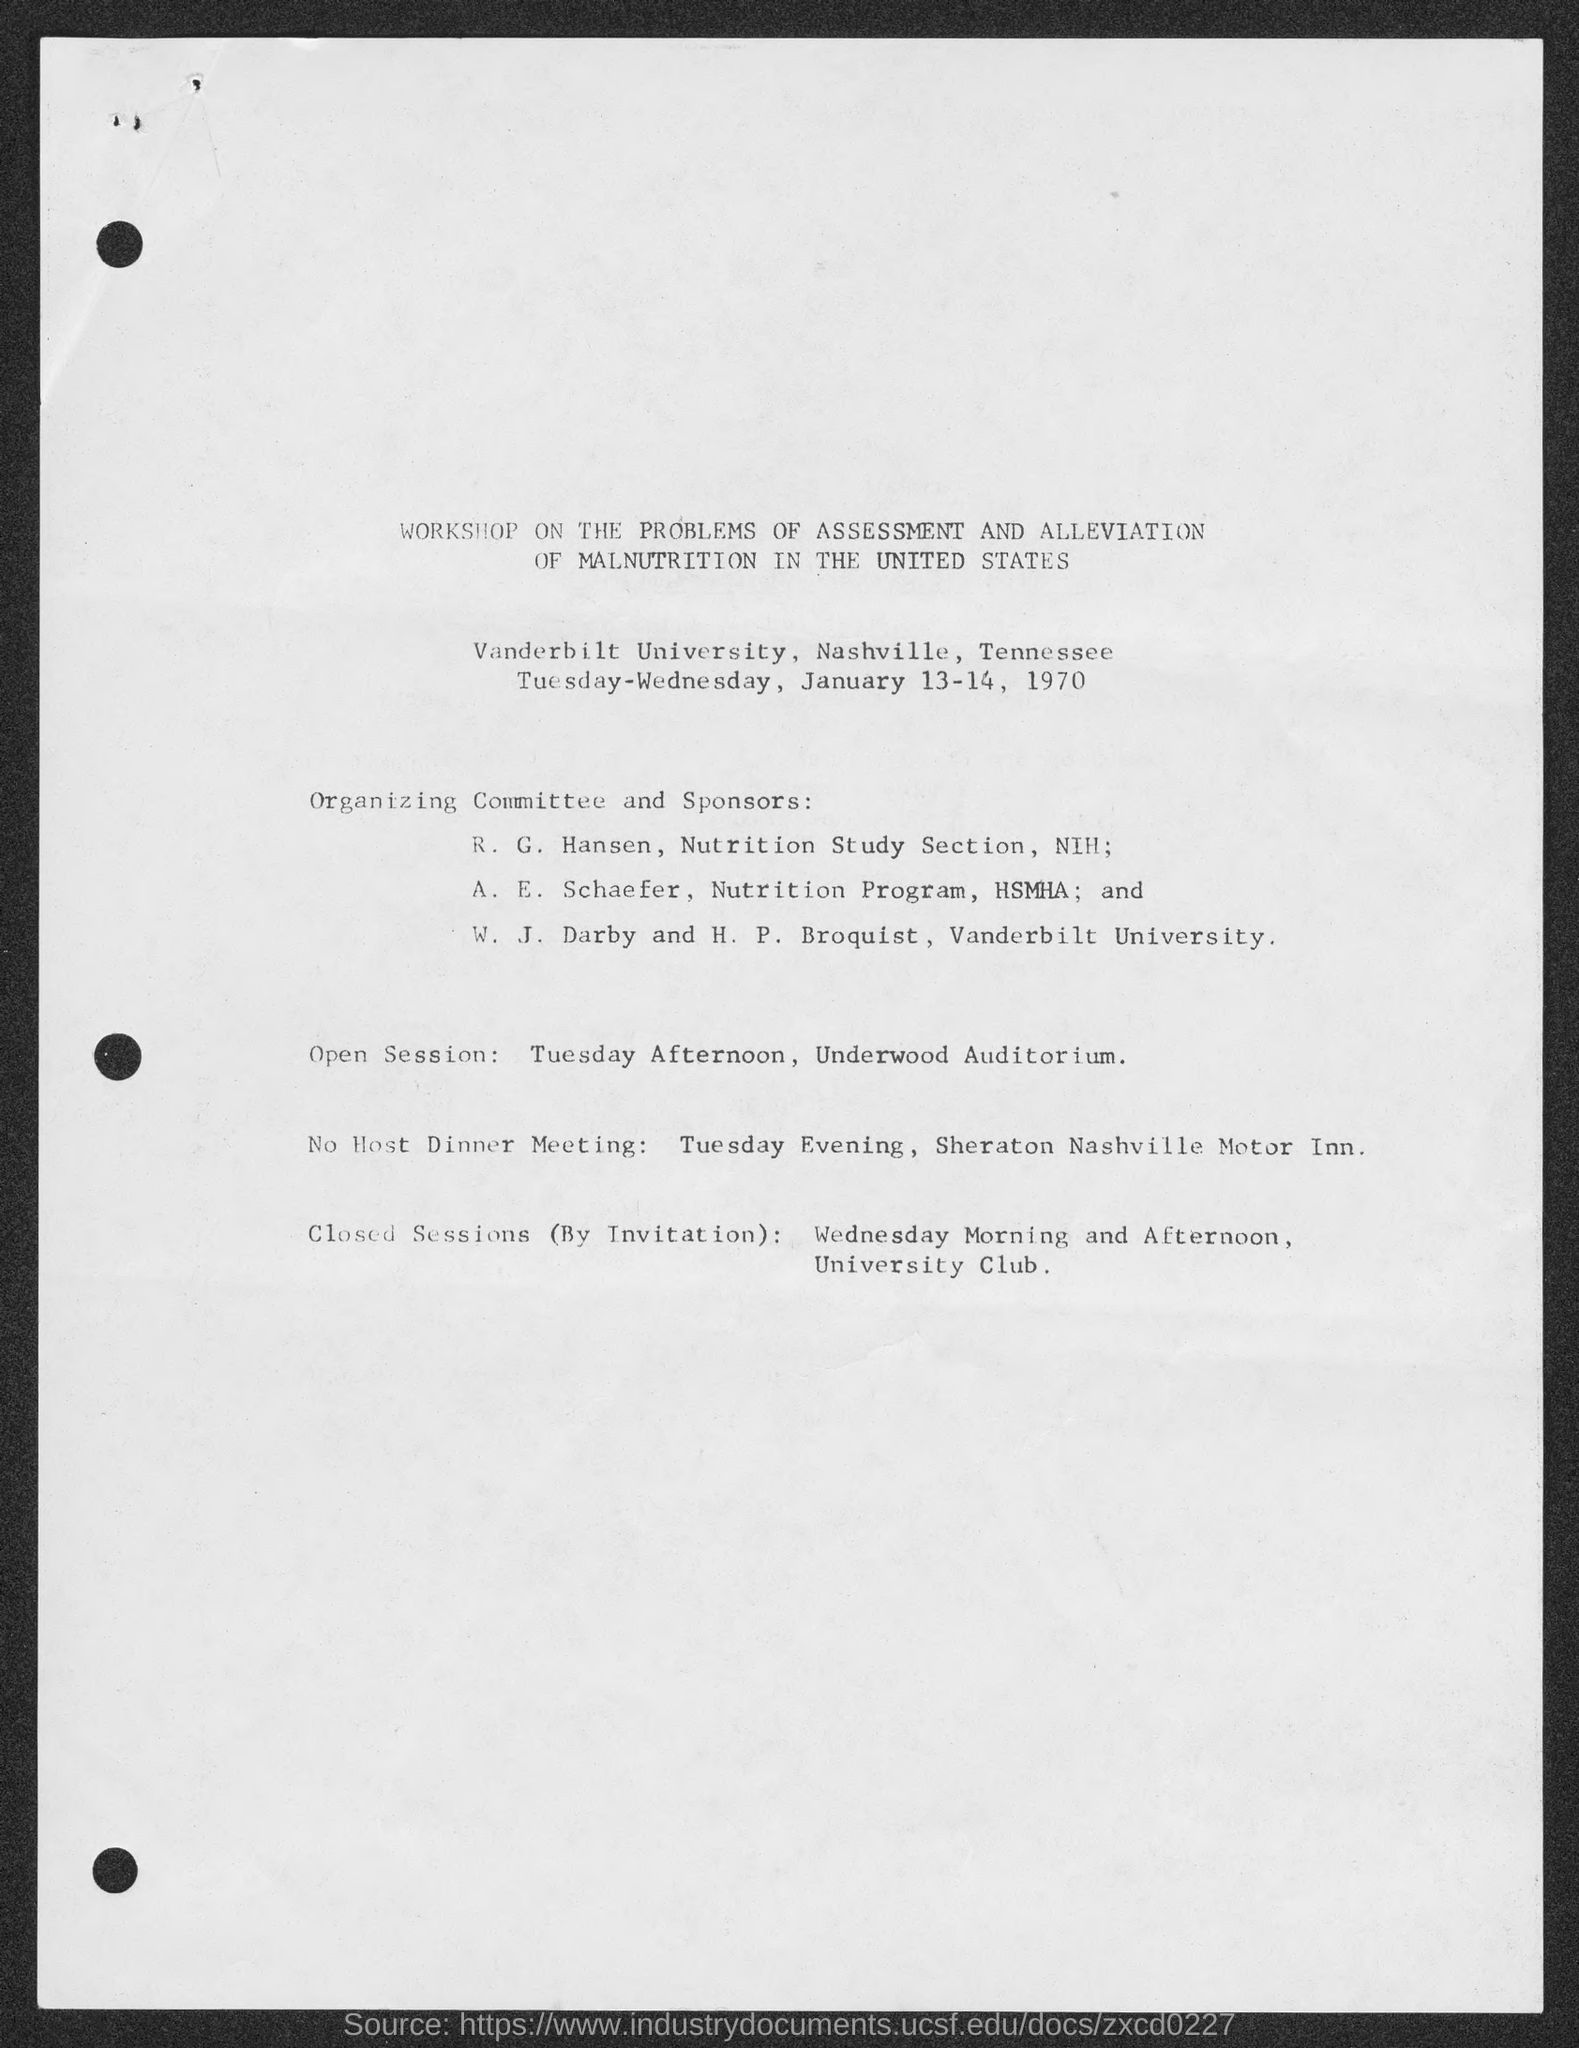Which university are W. J. Darby and H. P. Broquist associated with?
Your answer should be compact. Vanderbilt University. Where is the open session scheduled?
Offer a very short reply. Underwood Auditorium. When is the No Host Dinner Meeting scheduled?
Provide a succinct answer. January 13. Where are the closed sessions scheduled?
Offer a very short reply. University Club. 